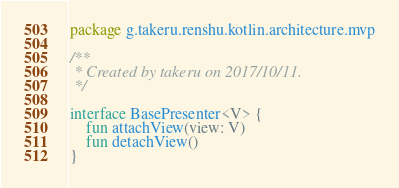<code> <loc_0><loc_0><loc_500><loc_500><_Kotlin_>package g.takeru.renshu.kotlin.architecture.mvp

/**
 * Created by takeru on 2017/10/11.
 */

interface BasePresenter<V> {
    fun attachView(view: V)
    fun detachView()
}
</code> 